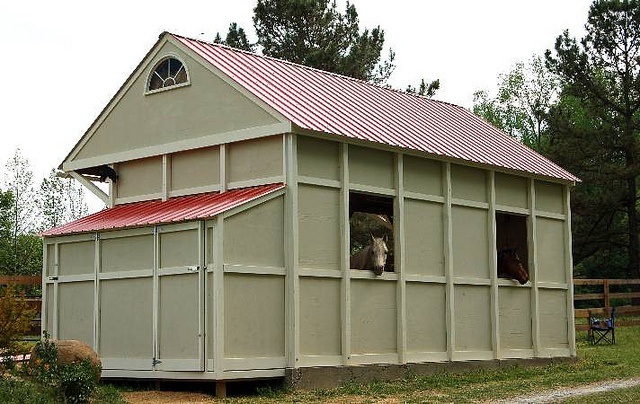Describe the objects in this image and their specific colors. I can see horse in white, black, maroon, darkgray, and gray tones, horse in white, black, and gray tones, and chair in white, black, darkgreen, and gray tones in this image. 